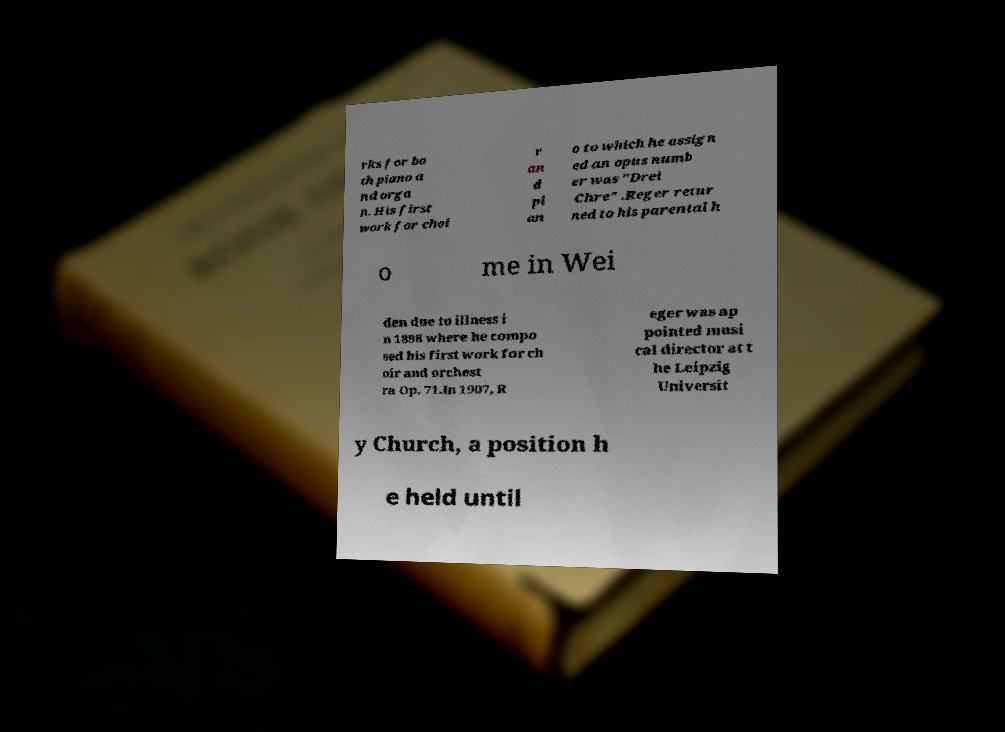Could you extract and type out the text from this image? rks for bo th piano a nd orga n. His first work for choi r an d pi an o to which he assign ed an opus numb er was "Drei Chre" .Reger retur ned to his parental h o me in Wei den due to illness i n 1898 where he compo sed his first work for ch oir and orchest ra Op. 71.In 1907, R eger was ap pointed musi cal director at t he Leipzig Universit y Church, a position h e held until 